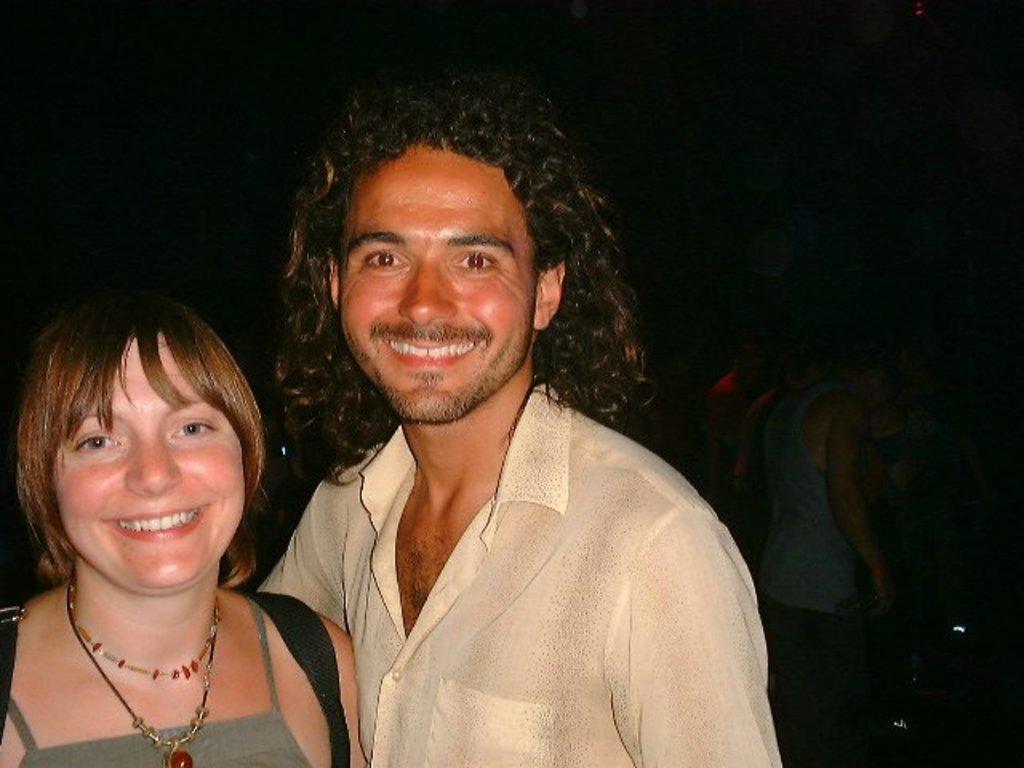Describe this image in one or two sentences. In this image, we can see a man and a woman standing and they are smiling, there is a dark background. 